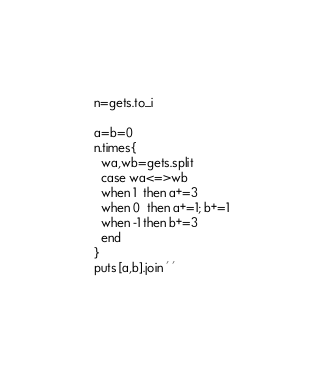Convert code to text. <code><loc_0><loc_0><loc_500><loc_500><_Ruby_>n=gets.to_i

a=b=0
n.times{
  wa,wb=gets.split
  case wa<=>wb
  when 1  then a+=3
  when 0  then a+=1; b+=1
  when -1 then b+=3
  end
}
puts [a,b].join ' '
</code> 